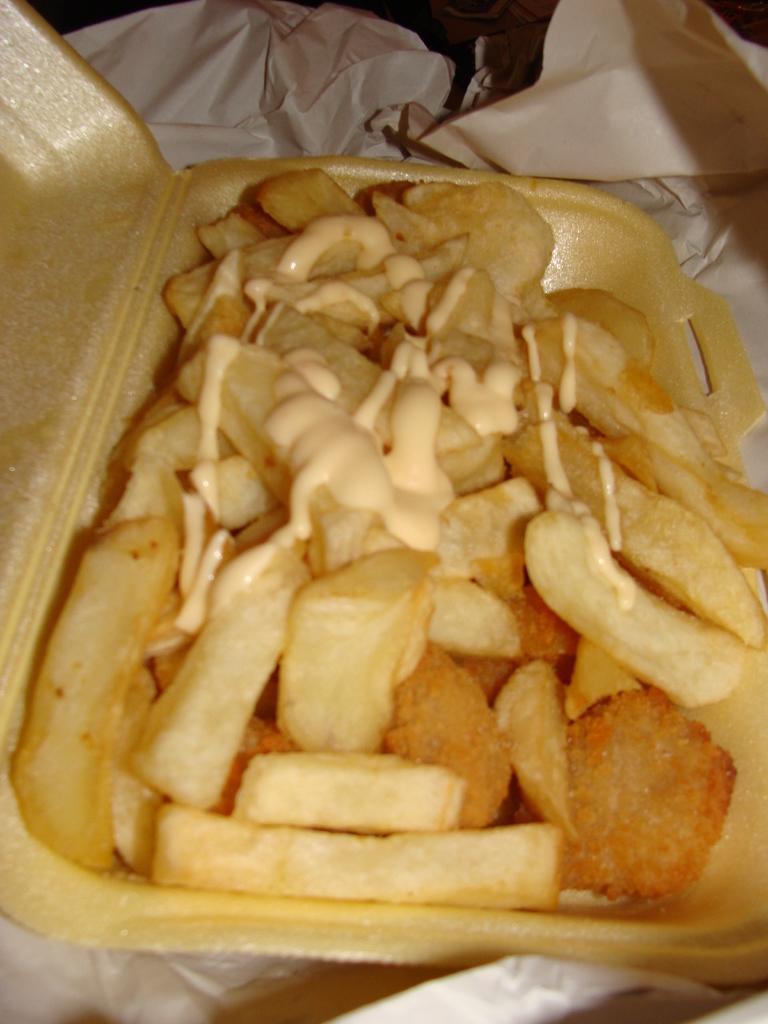Describe this image in one or two sentences. In the center of the image we can see french fries in bowl placed on the table. 